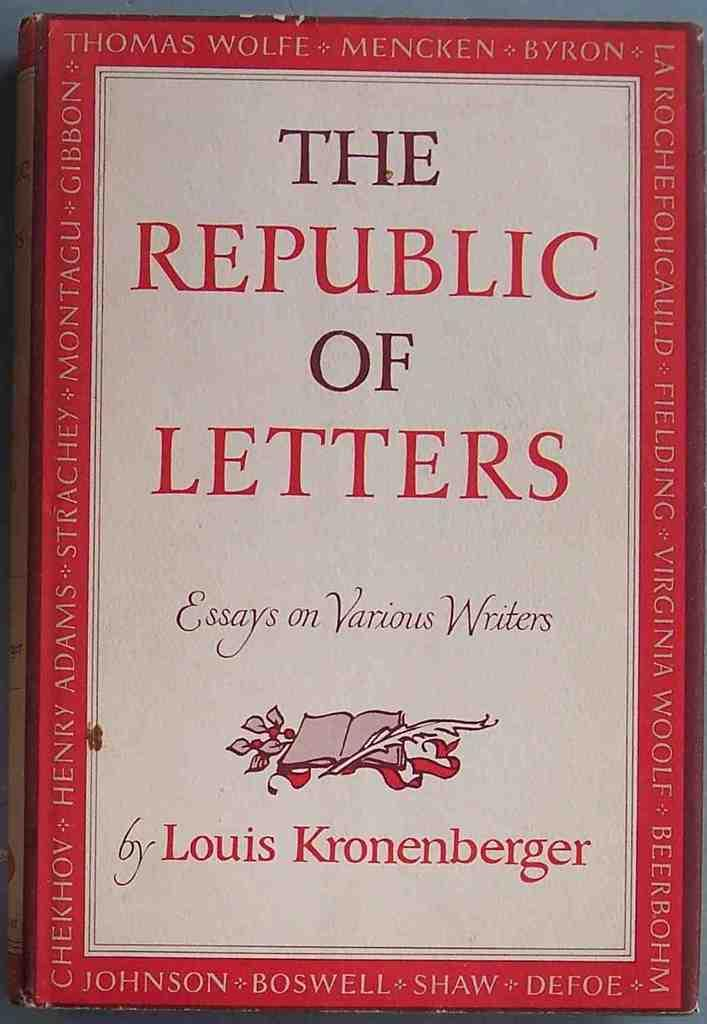<image>
Create a compact narrative representing the image presented. A book called The Republic of Letters containing the essays of various artists lies closed on a table. 